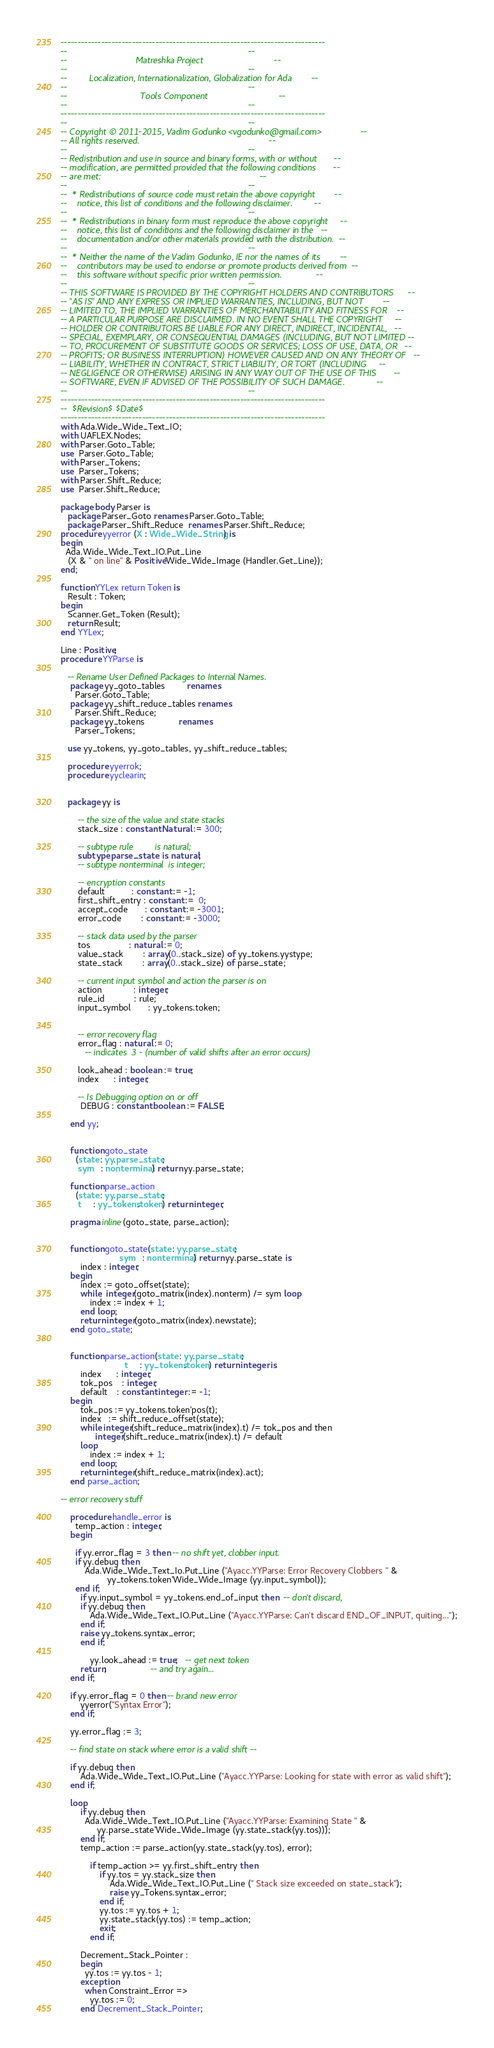Convert code to text. <code><loc_0><loc_0><loc_500><loc_500><_Ada_>------------------------------------------------------------------------------
--                                                                          --
--                            Matreshka Project                             --
--                                                                          --
--         Localization, Internationalization, Globalization for Ada        --
--                                                                          --
--                              Tools Component                             --
--                                                                          --
------------------------------------------------------------------------------
--                                                                          --
-- Copyright © 2011-2015, Vadim Godunko <vgodunko@gmail.com>                --
-- All rights reserved.                                                     --
--                                                                          --
-- Redistribution and use in source and binary forms, with or without       --
-- modification, are permitted provided that the following conditions       --
-- are met:                                                                 --
--                                                                          --
--  * Redistributions of source code must retain the above copyright        --
--    notice, this list of conditions and the following disclaimer.         --
--                                                                          --
--  * Redistributions in binary form must reproduce the above copyright     --
--    notice, this list of conditions and the following disclaimer in the   --
--    documentation and/or other materials provided with the distribution.  --
--                                                                          --
--  * Neither the name of the Vadim Godunko, IE nor the names of its        --
--    contributors may be used to endorse or promote products derived from  --
--    this software without specific prior written permission.              --
--                                                                          --
-- THIS SOFTWARE IS PROVIDED BY THE COPYRIGHT HOLDERS AND CONTRIBUTORS      --
-- "AS IS" AND ANY EXPRESS OR IMPLIED WARRANTIES, INCLUDING, BUT NOT        --
-- LIMITED TO, THE IMPLIED WARRANTIES OF MERCHANTABILITY AND FITNESS FOR    --
-- A PARTICULAR PURPOSE ARE DISCLAIMED. IN NO EVENT SHALL THE COPYRIGHT     --
-- HOLDER OR CONTRIBUTORS BE LIABLE FOR ANY DIRECT, INDIRECT, INCIDENTAL,   --
-- SPECIAL, EXEMPLARY, OR CONSEQUENTIAL DAMAGES (INCLUDING, BUT NOT LIMITED --
-- TO, PROCUREMENT OF SUBSTITUTE GOODS OR SERVICES; LOSS OF USE, DATA, OR   --
-- PROFITS; OR BUSINESS INTERRUPTION) HOWEVER CAUSED AND ON ANY THEORY OF   --
-- LIABILITY, WHETHER IN CONTRACT, STRICT LIABILITY, OR TORT (INCLUDING     --
-- NEGLIGENCE OR OTHERWISE) ARISING IN ANY WAY OUT OF THE USE OF THIS       --
-- SOFTWARE, EVEN IF ADVISED OF THE POSSIBILITY OF SUCH DAMAGE.             --
--                                                                          --
------------------------------------------------------------------------------
--  $Revision$ $Date$
------------------------------------------------------------------------------
with Ada.Wide_Wide_Text_IO;
with UAFLEX.Nodes;
with Parser.Goto_Table;
use  Parser.Goto_Table;
with Parser_Tokens;
use  Parser_Tokens;
with Parser.Shift_Reduce;
use  Parser.Shift_Reduce;

package body Parser is
   package Parser_Goto renames Parser.Goto_Table;
   package Parser_Shift_Reduce  renames Parser.Shift_Reduce;
procedure yyerror (X : Wide_Wide_String) is
begin
  Ada.Wide_Wide_Text_IO.Put_Line
   (X & " on line" & Positive'Wide_Wide_Image (Handler.Get_Line));
end;

function YYLex return Token is
   Result : Token;
begin
   Scanner.Get_Token (Result);
   return Result;
end YYLex;

Line : Positive;
procedure YYParse is

   -- Rename User Defined Packages to Internal Names.
    package yy_goto_tables         renames
      Parser.Goto_Table;
    package yy_shift_reduce_tables renames
      Parser.Shift_Reduce;
    package yy_tokens              renames
      Parser_Tokens;

   use yy_tokens, yy_goto_tables, yy_shift_reduce_tables;

   procedure yyerrok;
   procedure yyclearin;


   package yy is

       -- the size of the value and state stacks
       stack_size : constant Natural := 300;

       -- subtype rule         is natural;
       subtype parse_state  is natural;
       -- subtype nonterminal  is integer;

       -- encryption constants
       default           : constant := -1;
       first_shift_entry : constant :=  0;
       accept_code       : constant := -3001;
       error_code        : constant := -3000;

       -- stack data used by the parser
       tos                : natural := 0;
       value_stack        : array(0..stack_size) of yy_tokens.yystype;
       state_stack        : array(0..stack_size) of parse_state;

       -- current input symbol and action the parser is on
       action             : integer;
       rule_id            : rule;
       input_symbol       : yy_tokens.token;


       -- error recovery flag
       error_flag : natural := 0;
          -- indicates  3 - (number of valid shifts after an error occurs)

       look_ahead : boolean := true;
       index      : integer;

       -- Is Debugging option on or off
        DEBUG : constant boolean := FALSE;

    end yy;


    function goto_state
      (state : yy.parse_state;
       sym   : nonterminal) return yy.parse_state;

    function parse_action
      (state : yy.parse_state;
       t     : yy_tokens.token) return integer;

    pragma inline(goto_state, parse_action);


    function goto_state(state : yy.parse_state;
                        sym   : nonterminal) return yy.parse_state is
        index : integer;
    begin
        index := goto_offset(state);
        while  integer(goto_matrix(index).nonterm) /= sym loop
            index := index + 1;
        end loop;
        return integer(goto_matrix(index).newstate);
    end goto_state;


    function parse_action(state : yy.parse_state;
                          t     : yy_tokens.token) return integer is
        index      : integer;
        tok_pos    : integer;
        default    : constant integer := -1;
    begin
        tok_pos := yy_tokens.token'pos(t);
        index   := shift_reduce_offset(state);
        while integer(shift_reduce_matrix(index).t) /= tok_pos and then
              integer(shift_reduce_matrix(index).t) /= default
        loop
            index := index + 1;
        end loop;
        return integer(shift_reduce_matrix(index).act);
    end parse_action;

-- error recovery stuff

    procedure handle_error is
      temp_action : integer;
    begin

      if yy.error_flag = 3 then -- no shift yet, clobber input.
      if yy.debug then
          Ada.Wide_Wide_Text_Io.Put_Line ("Ayacc.YYParse: Error Recovery Clobbers " &
                   yy_tokens.token'Wide_Wide_Image (yy.input_symbol));
      end if;
        if yy.input_symbol = yy_tokens.end_of_input then  -- don't discard,
        if yy.debug then
            Ada.Wide_Wide_Text_IO.Put_Line ("Ayacc.YYParse: Can't discard END_OF_INPUT, quiting...");
        end if;
        raise yy_tokens.syntax_error;
        end if;

            yy.look_ahead := true;   -- get next token
        return;                  -- and try again...
    end if;

    if yy.error_flag = 0 then -- brand new error
        yyerror("Syntax Error");
    end if;

    yy.error_flag := 3;

    -- find state on stack where error is a valid shift --

    if yy.debug then
        Ada.Wide_Wide_Text_IO.Put_Line ("Ayacc.YYParse: Looking for state with error as valid shift");
    end if;

    loop
        if yy.debug then
          Ada.Wide_Wide_Text_IO.Put_Line ("Ayacc.YYParse: Examining State " &
               yy.parse_state'Wide_Wide_Image (yy.state_stack(yy.tos)));
        end if;
        temp_action := parse_action(yy.state_stack(yy.tos), error);

            if temp_action >= yy.first_shift_entry then
                if yy.tos = yy.stack_size then
                    Ada.Wide_Wide_Text_IO.Put_Line (" Stack size exceeded on state_stack");
                    raise yy_Tokens.syntax_error;
                end if;
                yy.tos := yy.tos + 1;
                yy.state_stack(yy.tos) := temp_action;
                exit;
            end if;

        Decrement_Stack_Pointer :
        begin
          yy.tos := yy.tos - 1;
        exception
          when Constraint_Error =>
            yy.tos := 0;
        end Decrement_Stack_Pointer;
</code> 